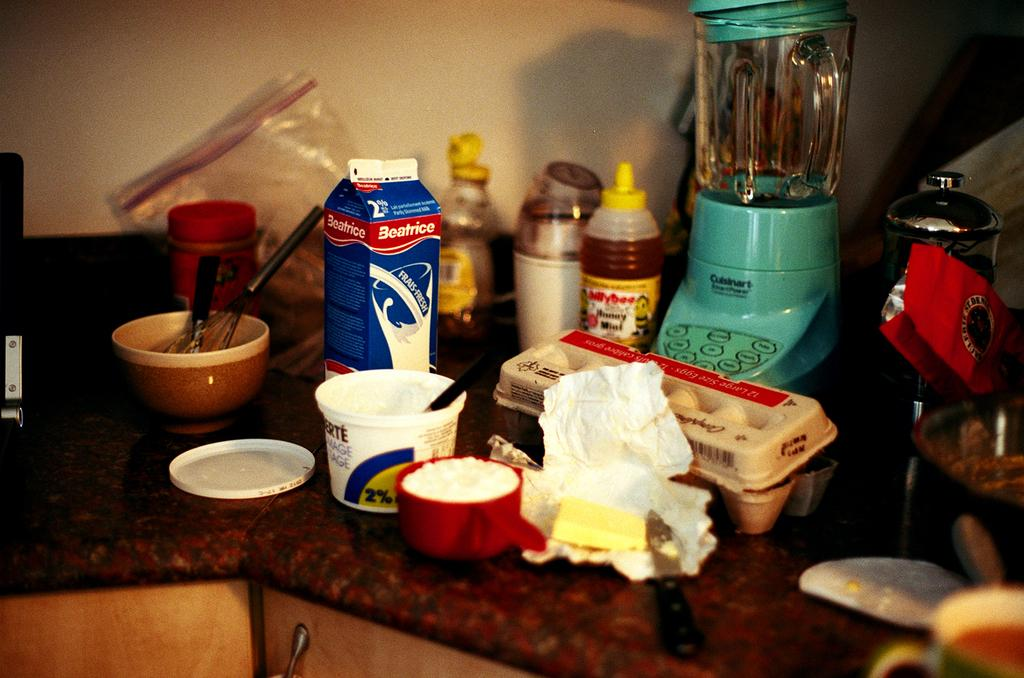<image>
Write a terse but informative summary of the picture. The kitchen counter has a carton of Beatrice 2% milk, eggs, and butter sitting in front of the blender. 